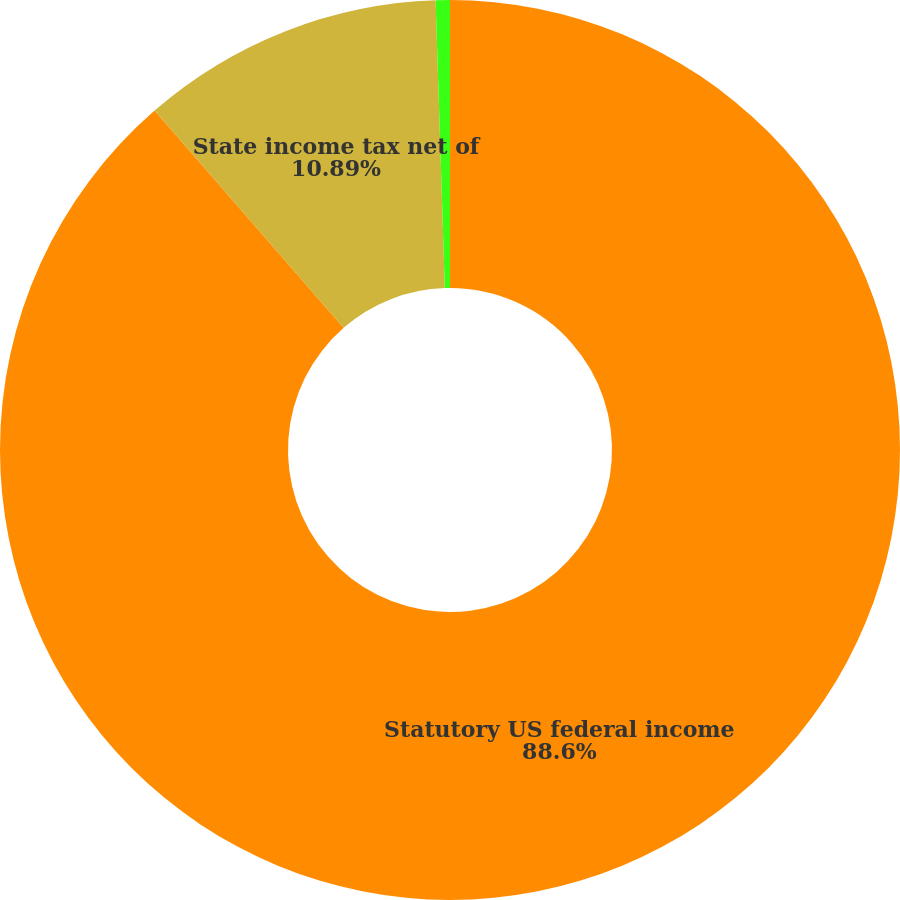Convert chart. <chart><loc_0><loc_0><loc_500><loc_500><pie_chart><fcel>Statutory US federal income<fcel>State income tax net of<fcel>Meals and entertainment<nl><fcel>88.61%<fcel>10.89%<fcel>0.51%<nl></chart> 